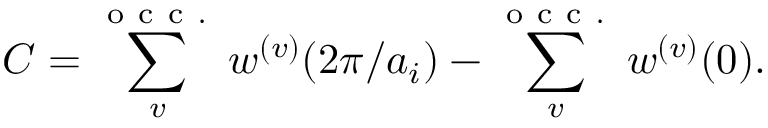<formula> <loc_0><loc_0><loc_500><loc_500>C = \sum _ { v } ^ { o c c . } w ^ { ( v ) } ( 2 \pi / a _ { i } ) - \sum _ { v } ^ { o c c . } w ^ { ( v ) } ( 0 ) .</formula> 